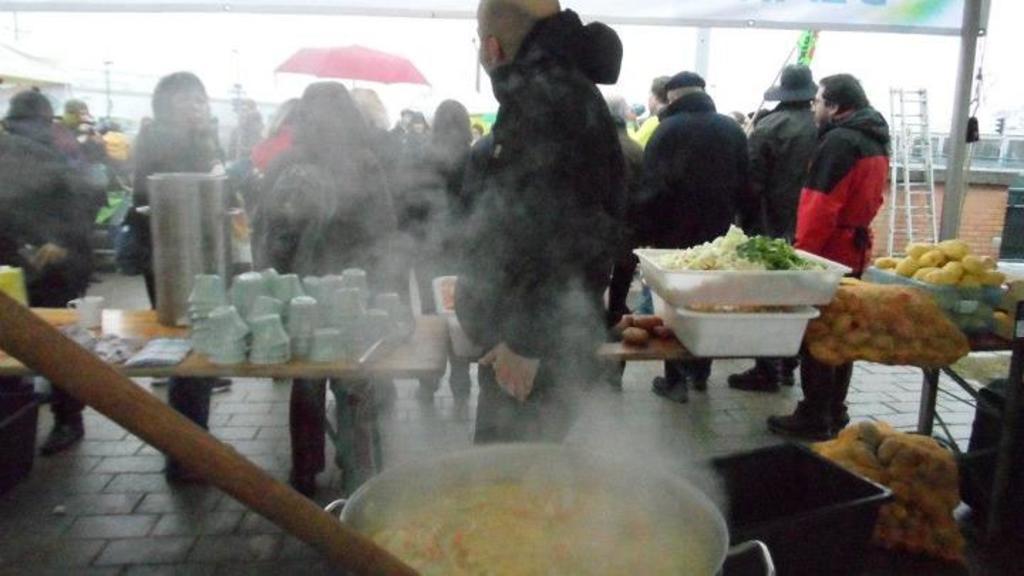How would you summarize this image in a sentence or two? In this image we can see the people standing and we can see an umbrella. There are tables, on the table, we can see there are cups, bowls and some vegetables. And we can see some food in the frying pan and there are few objects. Right side, we can see the wall and a ladder. 